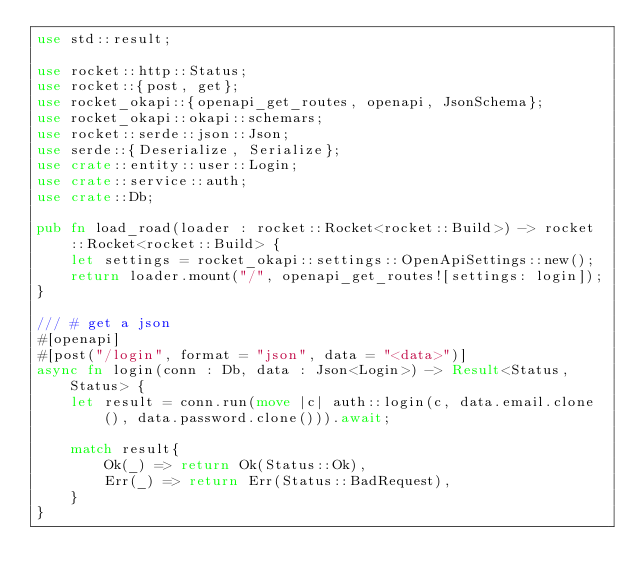Convert code to text. <code><loc_0><loc_0><loc_500><loc_500><_Rust_>use std::result;

use rocket::http::Status;
use rocket::{post, get};
use rocket_okapi::{openapi_get_routes, openapi, JsonSchema};
use rocket_okapi::okapi::schemars;
use rocket::serde::json::Json;
use serde::{Deserialize, Serialize};
use crate::entity::user::Login;
use crate::service::auth;
use crate::Db;

pub fn load_road(loader : rocket::Rocket<rocket::Build>) -> rocket::Rocket<rocket::Build> {
    let settings = rocket_okapi::settings::OpenApiSettings::new();
    return loader.mount("/", openapi_get_routes![settings: login]);
}

/// # get a json
#[openapi]
#[post("/login", format = "json", data = "<data>")]
async fn login(conn : Db, data : Json<Login>) -> Result<Status, Status> {
    let result = conn.run(move |c| auth::login(c, data.email.clone(), data.password.clone())).await;
    
    match result{
        Ok(_) => return Ok(Status::Ok),
        Err(_) => return Err(Status::BadRequest),
    }
}</code> 